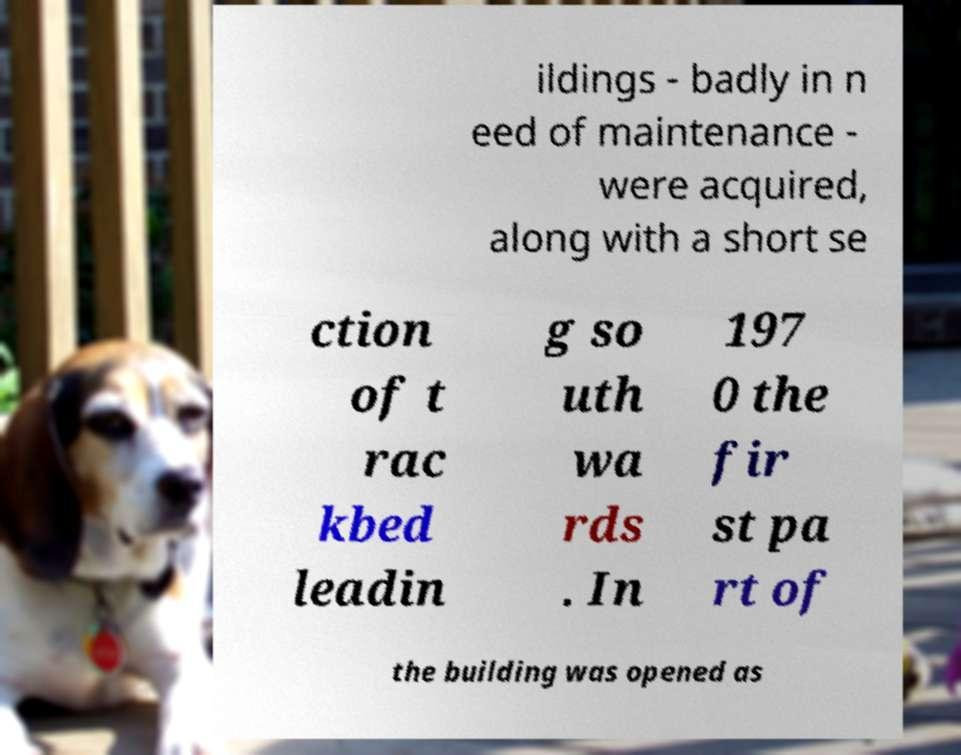I need the written content from this picture converted into text. Can you do that? ildings - badly in n eed of maintenance - were acquired, along with a short se ction of t rac kbed leadin g so uth wa rds . In 197 0 the fir st pa rt of the building was opened as 